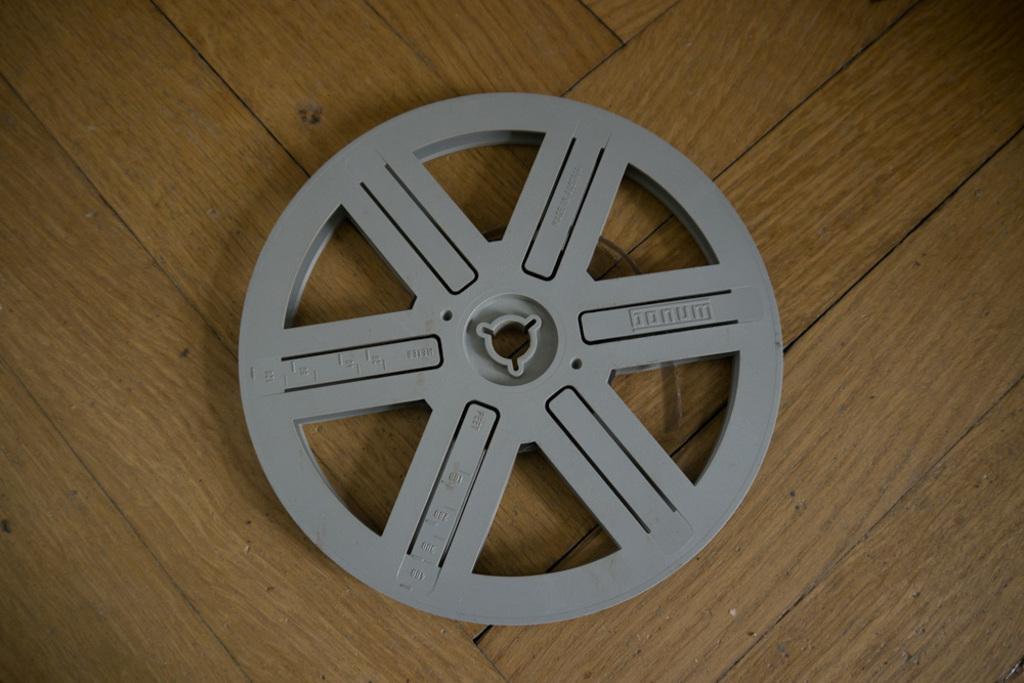Can you describe this image briefly? In the center of the image we can see a wheel placed on the table. 